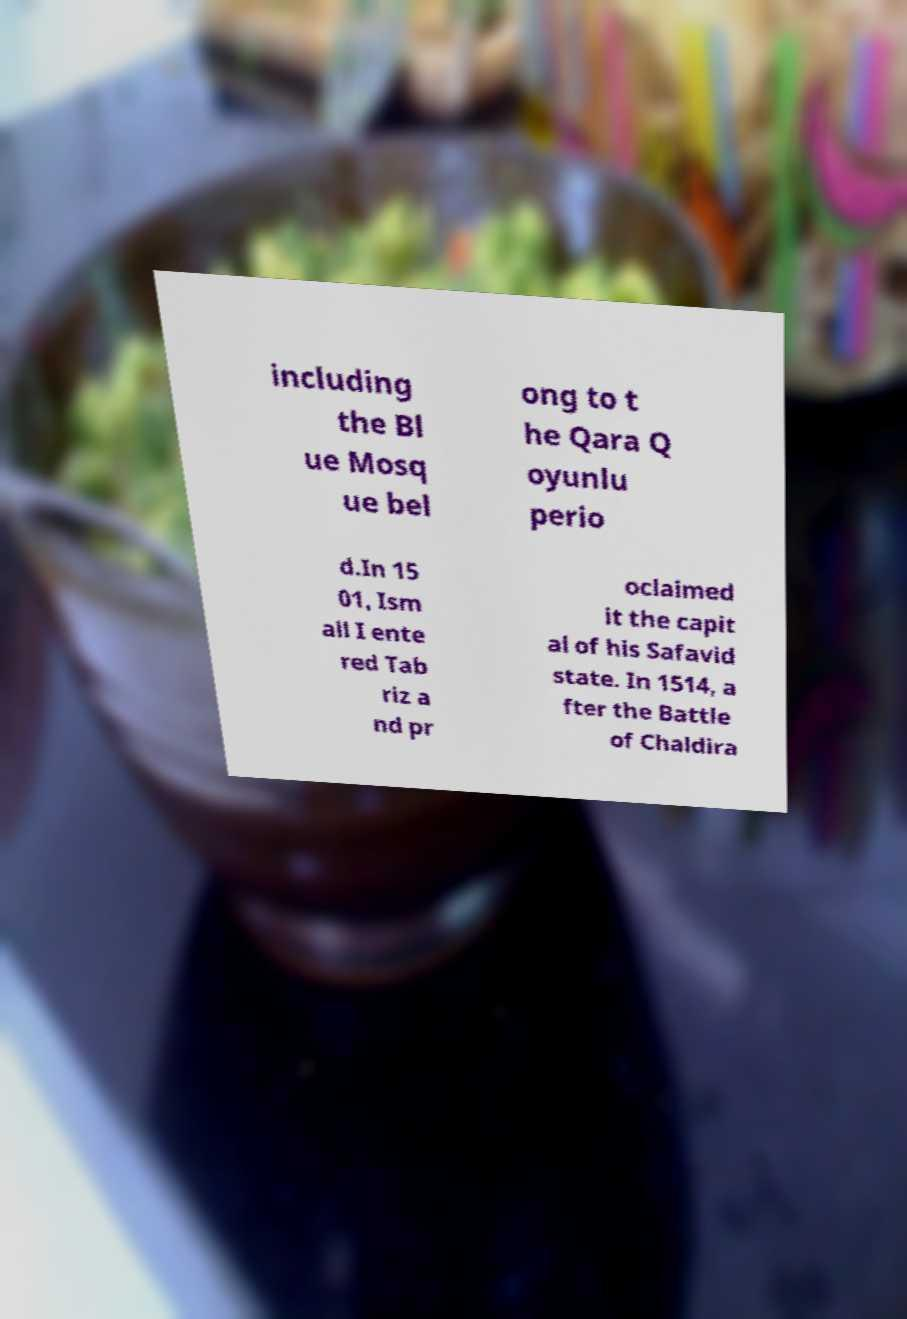Can you accurately transcribe the text from the provided image for me? including the Bl ue Mosq ue bel ong to t he Qara Q oyunlu perio d.In 15 01, Ism ail I ente red Tab riz a nd pr oclaimed it the capit al of his Safavid state. In 1514, a fter the Battle of Chaldira 